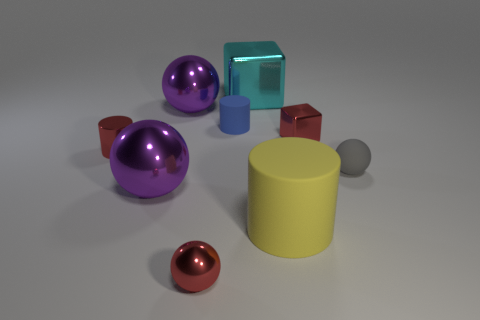The other small object that is the same shape as the gray thing is what color? The small object sharing the same spherical shape as the gray sphere is colored red. 